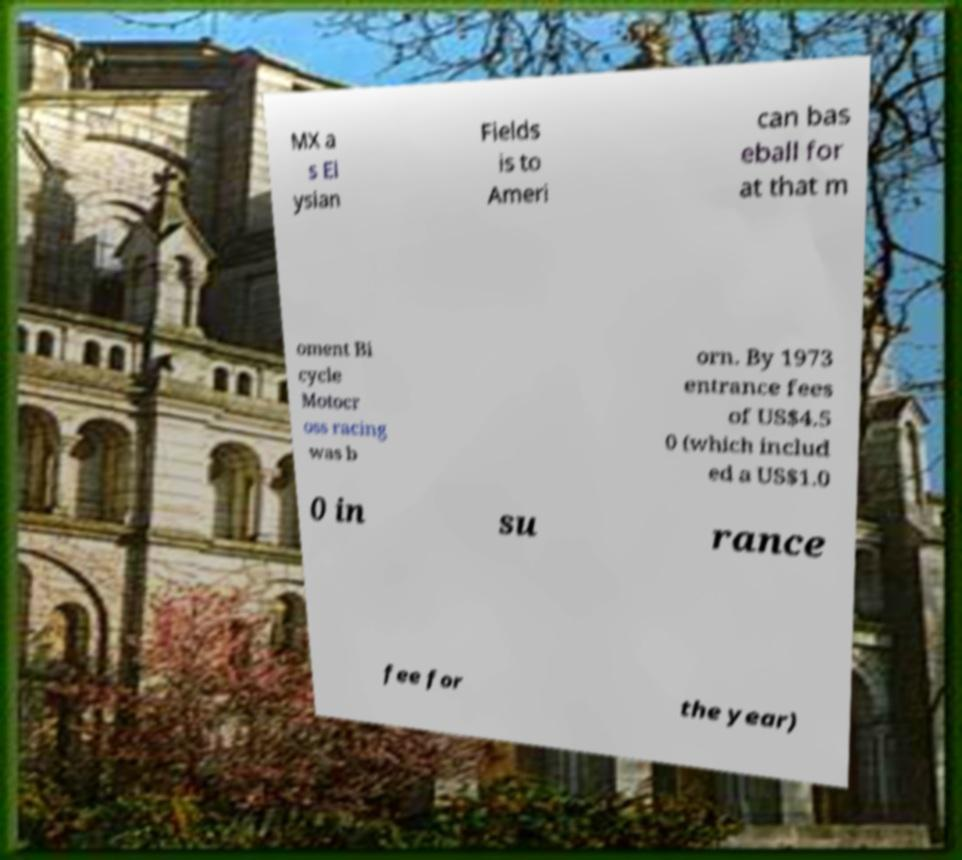Can you read and provide the text displayed in the image?This photo seems to have some interesting text. Can you extract and type it out for me? MX a s El ysian Fields is to Ameri can bas eball for at that m oment Bi cycle Motocr oss racing was b orn. By 1973 entrance fees of US$4.5 0 (which includ ed a US$1.0 0 in su rance fee for the year) 